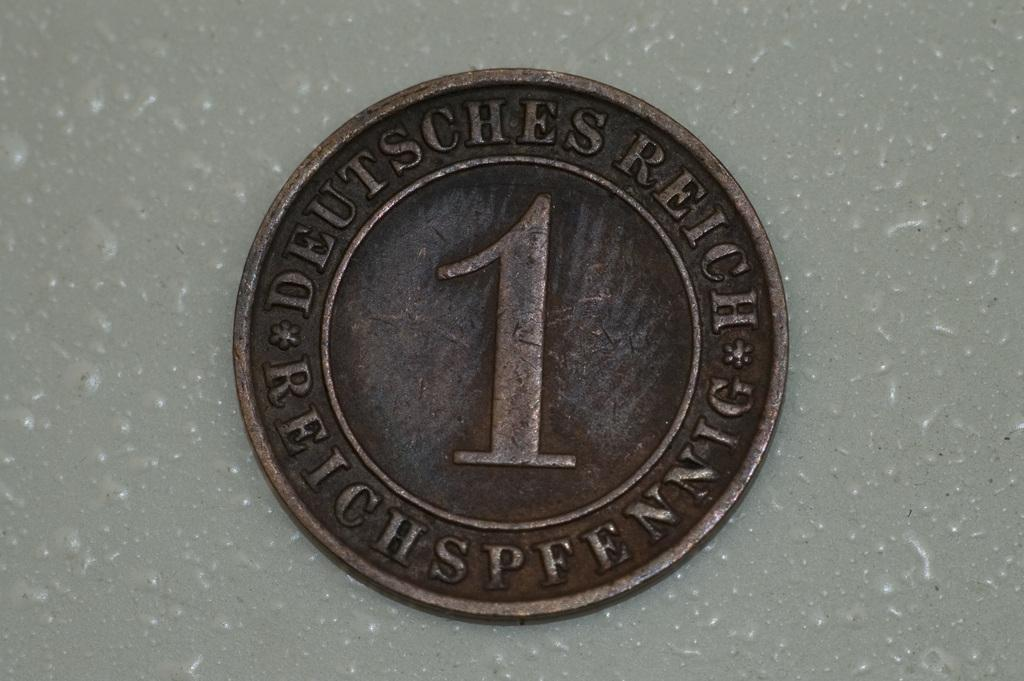<image>
Create a compact narrative representing the image presented. a copper colored coin with a 1 and the words Deutshess Reich is stamped on it 